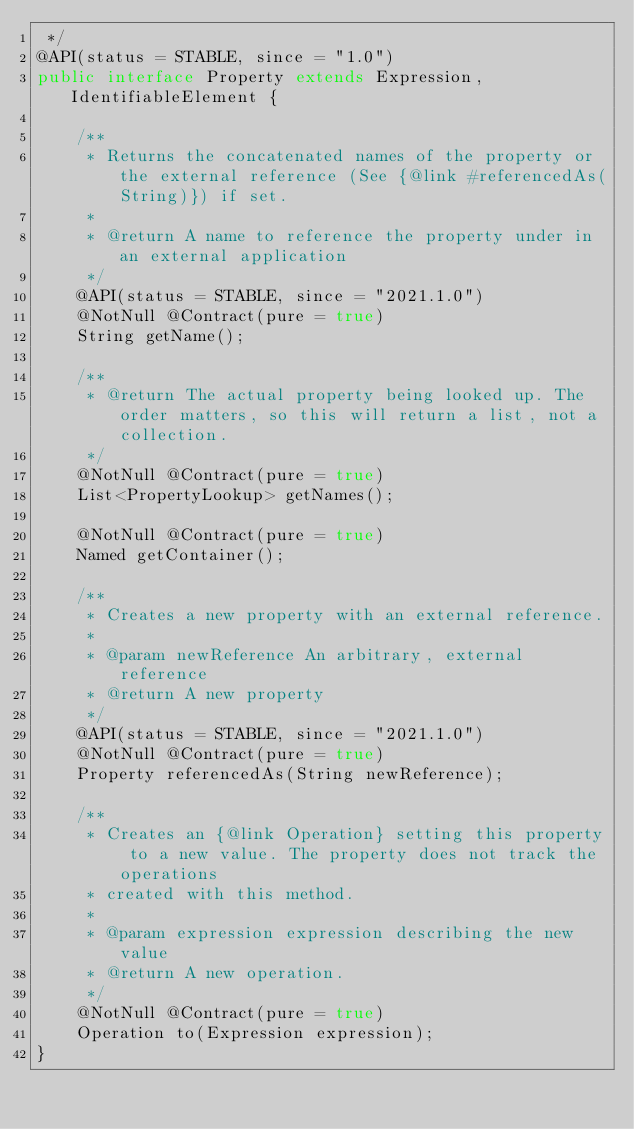<code> <loc_0><loc_0><loc_500><loc_500><_Java_> */
@API(status = STABLE, since = "1.0")
public interface Property extends Expression, IdentifiableElement {

	/**
	 * Returns the concatenated names of the property or the external reference (See {@link #referencedAs(String)}) if set.
	 *
	 * @return A name to reference the property under in an external application
	 */
	@API(status = STABLE, since = "2021.1.0")
	@NotNull @Contract(pure = true)
	String getName();

	/**
	 * @return The actual property being looked up. The order matters, so this will return a list, not a collection.
	 */
	@NotNull @Contract(pure = true)
	List<PropertyLookup> getNames();

	@NotNull @Contract(pure = true)
	Named getContainer();

	/**
	 * Creates a new property with an external reference.
	 *
	 * @param newReference An arbitrary, external reference
	 * @return A new property
	 */
	@API(status = STABLE, since = "2021.1.0")
	@NotNull @Contract(pure = true)
	Property referencedAs(String newReference);

	/**
	 * Creates an {@link Operation} setting this property to a new value. The property does not track the operations
	 * created with this method.
	 *
	 * @param expression expression describing the new value
	 * @return A new operation.
	 */
	@NotNull @Contract(pure = true)
	Operation to(Expression expression);
}
</code> 